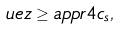<formula> <loc_0><loc_0><loc_500><loc_500>\ u e z \geq a p p r 4 c _ { s } ,</formula> 